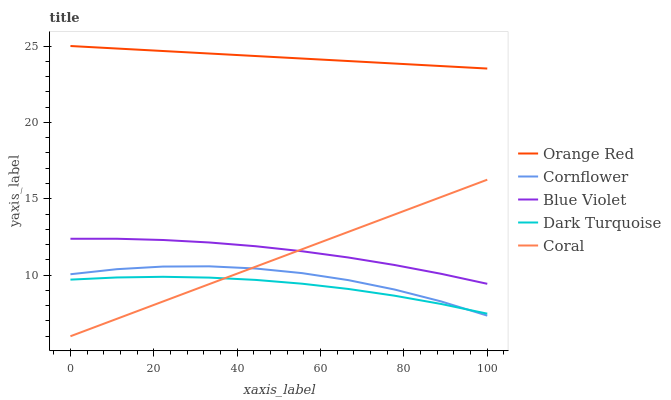Does Dark Turquoise have the minimum area under the curve?
Answer yes or no. Yes. Does Orange Red have the maximum area under the curve?
Answer yes or no. Yes. Does Coral have the minimum area under the curve?
Answer yes or no. No. Does Coral have the maximum area under the curve?
Answer yes or no. No. Is Coral the smoothest?
Answer yes or no. Yes. Is Cornflower the roughest?
Answer yes or no. Yes. Is Orange Red the smoothest?
Answer yes or no. No. Is Orange Red the roughest?
Answer yes or no. No. Does Orange Red have the lowest value?
Answer yes or no. No. Does Coral have the highest value?
Answer yes or no. No. Is Dark Turquoise less than Blue Violet?
Answer yes or no. Yes. Is Blue Violet greater than Cornflower?
Answer yes or no. Yes. Does Dark Turquoise intersect Blue Violet?
Answer yes or no. No. 